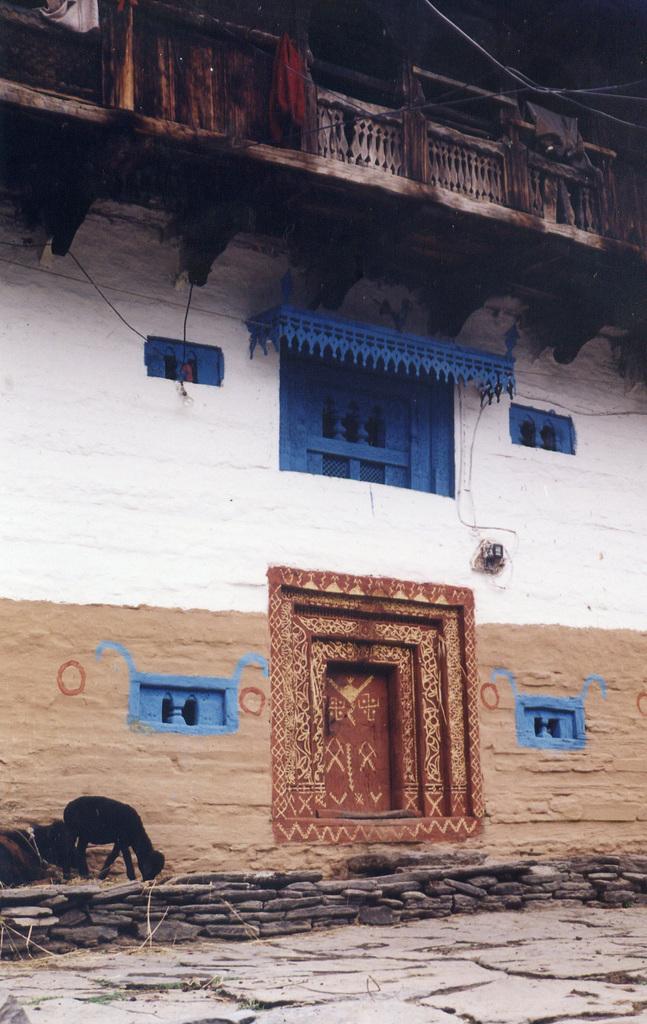Can you describe this image briefly? In this image we can see a building with door and windows. To the left side of the image there are goats. At the bottom of the image there is flooring. 